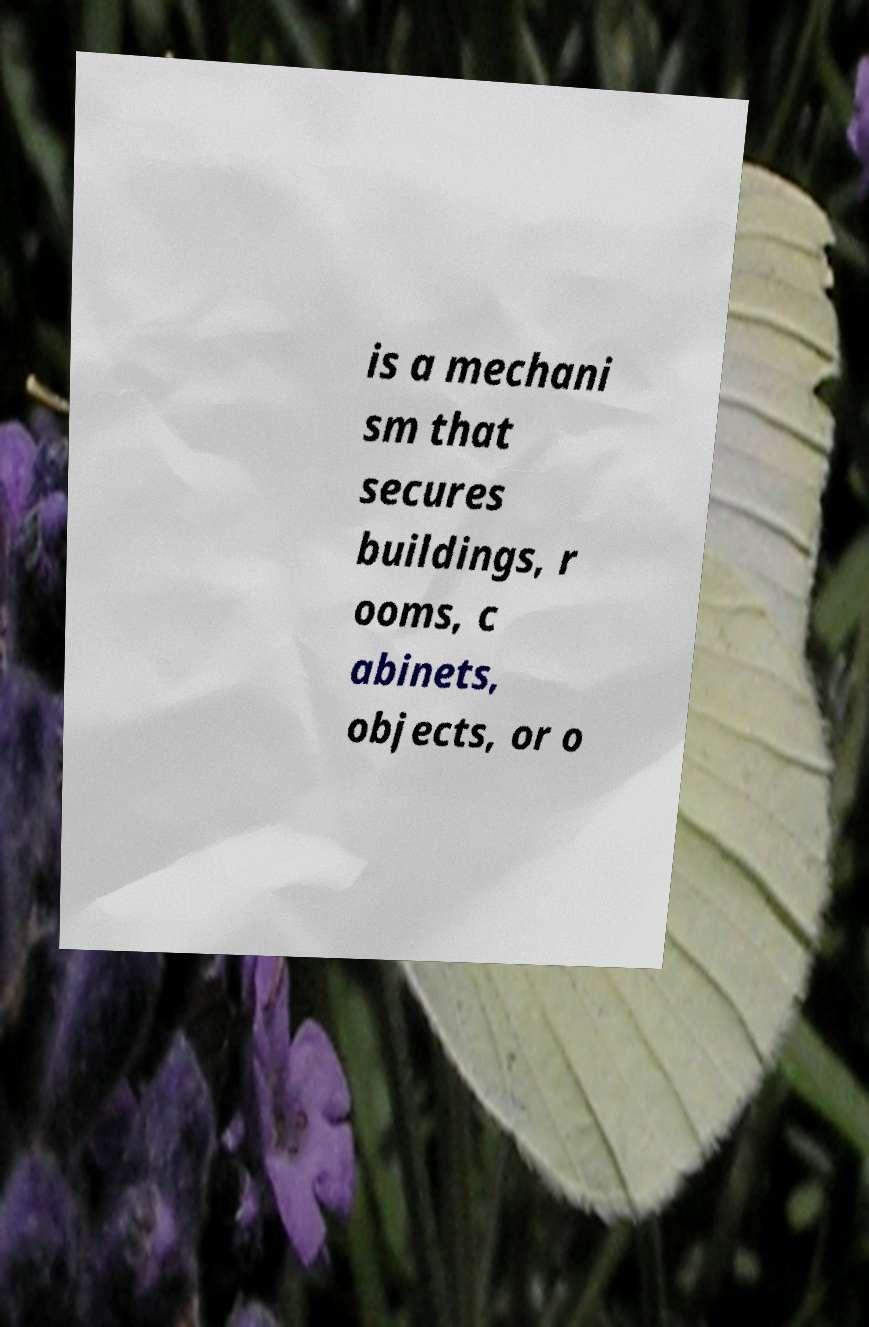Could you assist in decoding the text presented in this image and type it out clearly? is a mechani sm that secures buildings, r ooms, c abinets, objects, or o 